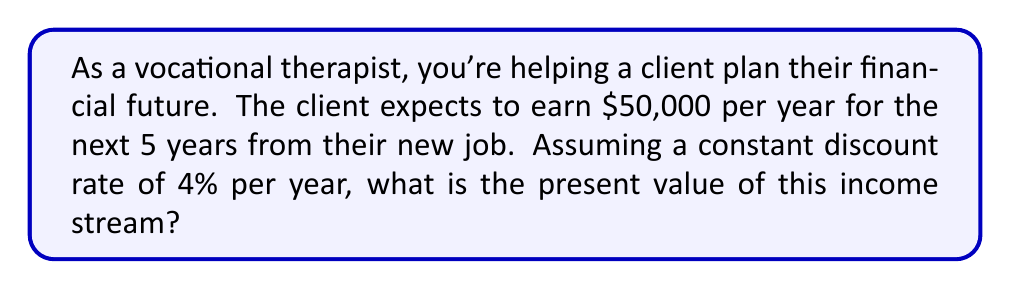Give your solution to this math problem. To solve this problem, we need to use the present value formula for an annuity. The formula is:

$$ PV = A \cdot \frac{1 - (1+r)^{-n}}{r} $$

Where:
$PV$ = Present Value
$A$ = Annual payment (income in this case)
$r$ = Discount rate (as a decimal)
$n$ = Number of years

Given:
$A = \$50,000$
$r = 0.04$ (4% expressed as a decimal)
$n = 5$ years

Let's substitute these values into the formula:

$$ PV = 50,000 \cdot \frac{1 - (1+0.04)^{-5}}{0.04} $$

Now, let's solve step by step:

1) First, calculate $(1+0.04)^{-5}$:
   $(1.04)^{-5} = 0.8219$

2) Subtract this from 1:
   $1 - 0.8219 = 0.1781$

3) Divide by 0.04:
   $0.1781 \div 0.04 = 4.4525$

4) Multiply by 50,000:
   $50,000 \times 4.4525 = 222,625$

Therefore, the present value of the income stream is $222,625.
Answer: $222,625 